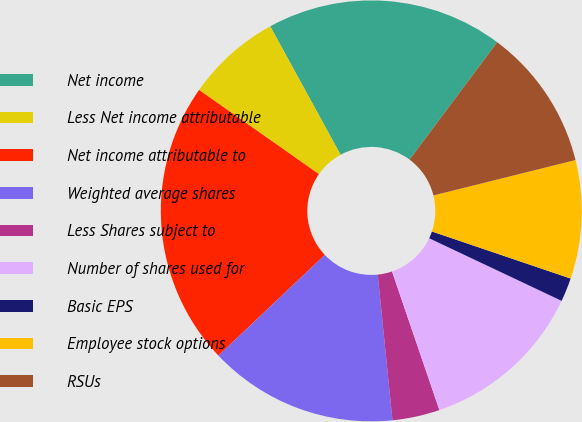Convert chart. <chart><loc_0><loc_0><loc_500><loc_500><pie_chart><fcel>Net income<fcel>Less Net income attributable<fcel>Net income attributable to<fcel>Weighted average shares<fcel>Less Shares subject to<fcel>Number of shares used for<fcel>Basic EPS<fcel>Employee stock options<fcel>RSUs<nl><fcel>18.18%<fcel>7.28%<fcel>21.81%<fcel>14.54%<fcel>3.64%<fcel>12.73%<fcel>1.82%<fcel>9.09%<fcel>10.91%<nl></chart> 